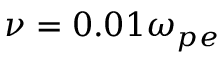<formula> <loc_0><loc_0><loc_500><loc_500>\nu = 0 . 0 1 \omega _ { p e }</formula> 